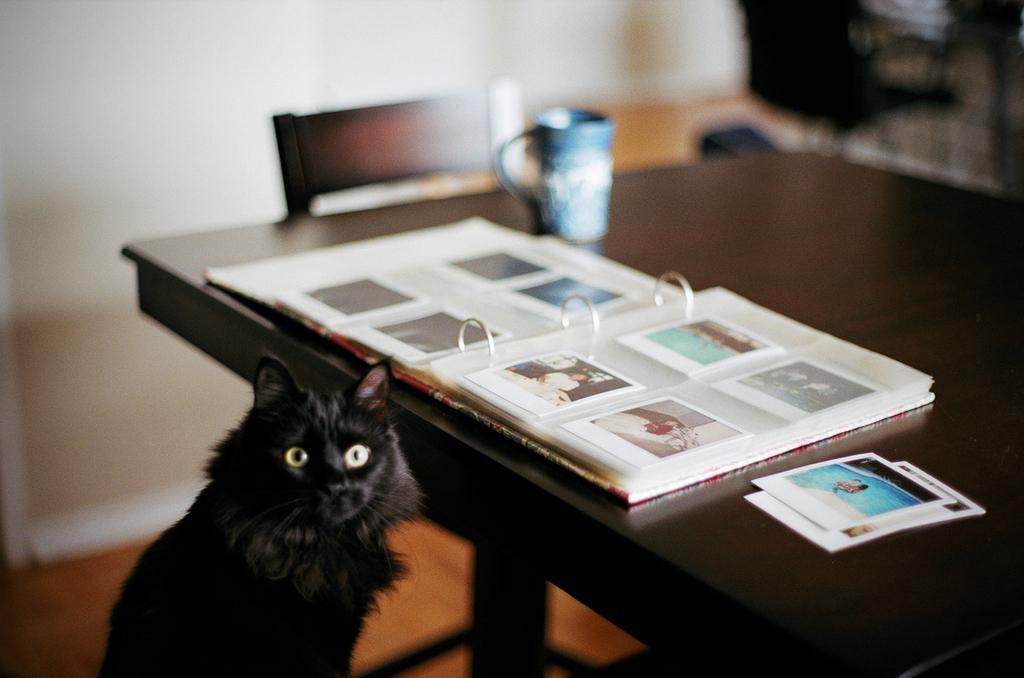In one or two sentences, can you explain what this image depicts? This picture shows a album and we see couple of photos on the table and we see a cup and a chair and we see a black cat. 